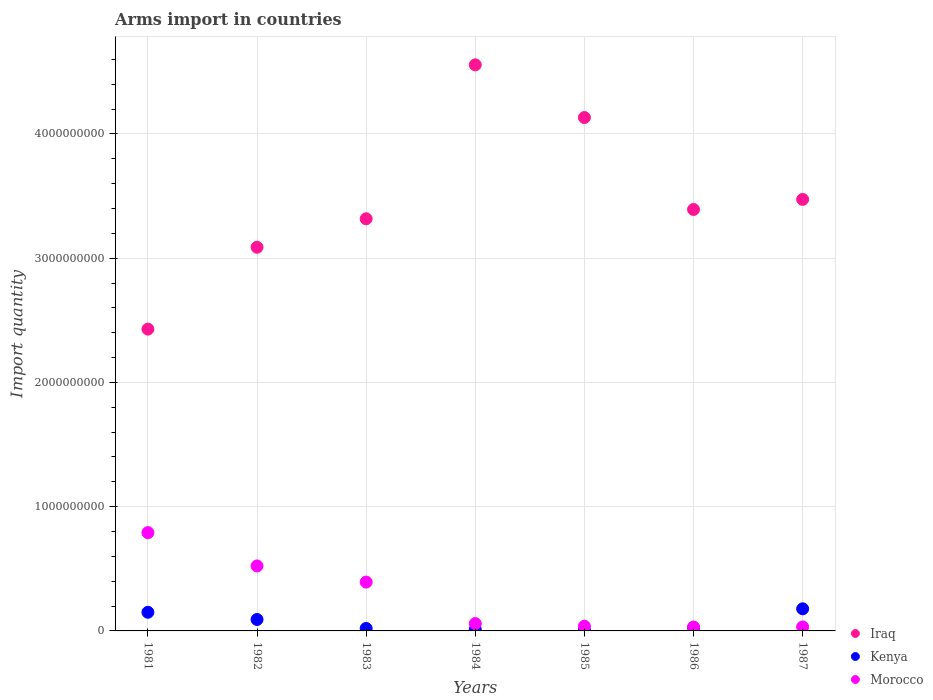What is the total arms import in Morocco in 1984?
Provide a short and direct response. 5.90e+07. Across all years, what is the maximum total arms import in Iraq?
Your answer should be very brief. 4.56e+09. Across all years, what is the minimum total arms import in Morocco?
Provide a succinct answer. 3.10e+07. In which year was the total arms import in Kenya maximum?
Your response must be concise. 1987. What is the total total arms import in Morocco in the graph?
Provide a short and direct response. 1.87e+09. What is the difference between the total arms import in Morocco in 1981 and that in 1982?
Make the answer very short. 2.68e+08. What is the difference between the total arms import in Morocco in 1985 and the total arms import in Iraq in 1983?
Make the answer very short. -3.28e+09. What is the average total arms import in Iraq per year?
Give a very brief answer. 3.48e+09. In the year 1984, what is the difference between the total arms import in Iraq and total arms import in Kenya?
Your answer should be compact. 4.54e+09. What is the ratio of the total arms import in Iraq in 1983 to that in 1984?
Ensure brevity in your answer.  0.73. Is the total arms import in Kenya in 1982 less than that in 1984?
Ensure brevity in your answer.  No. What is the difference between the highest and the second highest total arms import in Morocco?
Keep it short and to the point. 2.68e+08. What is the difference between the highest and the lowest total arms import in Morocco?
Keep it short and to the point. 7.60e+08. How many dotlines are there?
Offer a very short reply. 3. How many years are there in the graph?
Offer a very short reply. 7. What is the difference between two consecutive major ticks on the Y-axis?
Keep it short and to the point. 1.00e+09. Are the values on the major ticks of Y-axis written in scientific E-notation?
Make the answer very short. No. Does the graph contain any zero values?
Provide a succinct answer. No. Does the graph contain grids?
Your answer should be very brief. Yes. How are the legend labels stacked?
Offer a terse response. Vertical. What is the title of the graph?
Keep it short and to the point. Arms import in countries. Does "Marshall Islands" appear as one of the legend labels in the graph?
Offer a very short reply. No. What is the label or title of the Y-axis?
Make the answer very short. Import quantity. What is the Import quantity in Iraq in 1981?
Offer a very short reply. 2.43e+09. What is the Import quantity of Kenya in 1981?
Your response must be concise. 1.50e+08. What is the Import quantity in Morocco in 1981?
Provide a succinct answer. 7.91e+08. What is the Import quantity of Iraq in 1982?
Your response must be concise. 3.09e+09. What is the Import quantity of Kenya in 1982?
Offer a terse response. 9.20e+07. What is the Import quantity in Morocco in 1982?
Keep it short and to the point. 5.23e+08. What is the Import quantity in Iraq in 1983?
Make the answer very short. 3.32e+09. What is the Import quantity in Morocco in 1983?
Provide a succinct answer. 3.93e+08. What is the Import quantity in Iraq in 1984?
Ensure brevity in your answer.  4.56e+09. What is the Import quantity of Kenya in 1984?
Keep it short and to the point. 1.20e+07. What is the Import quantity of Morocco in 1984?
Your response must be concise. 5.90e+07. What is the Import quantity of Iraq in 1985?
Your answer should be compact. 4.13e+09. What is the Import quantity in Morocco in 1985?
Offer a terse response. 3.80e+07. What is the Import quantity in Iraq in 1986?
Offer a terse response. 3.39e+09. What is the Import quantity in Kenya in 1986?
Ensure brevity in your answer.  2.60e+07. What is the Import quantity in Morocco in 1986?
Provide a short and direct response. 3.10e+07. What is the Import quantity of Iraq in 1987?
Offer a very short reply. 3.47e+09. What is the Import quantity of Kenya in 1987?
Ensure brevity in your answer.  1.78e+08. What is the Import quantity of Morocco in 1987?
Your answer should be very brief. 3.20e+07. Across all years, what is the maximum Import quantity of Iraq?
Your answer should be compact. 4.56e+09. Across all years, what is the maximum Import quantity of Kenya?
Provide a short and direct response. 1.78e+08. Across all years, what is the maximum Import quantity of Morocco?
Offer a terse response. 7.91e+08. Across all years, what is the minimum Import quantity in Iraq?
Provide a short and direct response. 2.43e+09. Across all years, what is the minimum Import quantity in Morocco?
Keep it short and to the point. 3.10e+07. What is the total Import quantity of Iraq in the graph?
Offer a terse response. 2.44e+1. What is the total Import quantity in Kenya in the graph?
Ensure brevity in your answer.  4.84e+08. What is the total Import quantity of Morocco in the graph?
Provide a short and direct response. 1.87e+09. What is the difference between the Import quantity of Iraq in 1981 and that in 1982?
Give a very brief answer. -6.59e+08. What is the difference between the Import quantity of Kenya in 1981 and that in 1982?
Provide a short and direct response. 5.80e+07. What is the difference between the Import quantity in Morocco in 1981 and that in 1982?
Keep it short and to the point. 2.68e+08. What is the difference between the Import quantity in Iraq in 1981 and that in 1983?
Your answer should be very brief. -8.88e+08. What is the difference between the Import quantity in Kenya in 1981 and that in 1983?
Ensure brevity in your answer.  1.30e+08. What is the difference between the Import quantity of Morocco in 1981 and that in 1983?
Provide a succinct answer. 3.98e+08. What is the difference between the Import quantity of Iraq in 1981 and that in 1984?
Give a very brief answer. -2.13e+09. What is the difference between the Import quantity in Kenya in 1981 and that in 1984?
Provide a short and direct response. 1.38e+08. What is the difference between the Import quantity in Morocco in 1981 and that in 1984?
Keep it short and to the point. 7.32e+08. What is the difference between the Import quantity in Iraq in 1981 and that in 1985?
Your response must be concise. -1.70e+09. What is the difference between the Import quantity in Kenya in 1981 and that in 1985?
Provide a short and direct response. 1.44e+08. What is the difference between the Import quantity of Morocco in 1981 and that in 1985?
Your answer should be compact. 7.53e+08. What is the difference between the Import quantity of Iraq in 1981 and that in 1986?
Make the answer very short. -9.63e+08. What is the difference between the Import quantity in Kenya in 1981 and that in 1986?
Your response must be concise. 1.24e+08. What is the difference between the Import quantity of Morocco in 1981 and that in 1986?
Your response must be concise. 7.60e+08. What is the difference between the Import quantity in Iraq in 1981 and that in 1987?
Offer a terse response. -1.04e+09. What is the difference between the Import quantity of Kenya in 1981 and that in 1987?
Offer a very short reply. -2.80e+07. What is the difference between the Import quantity of Morocco in 1981 and that in 1987?
Make the answer very short. 7.59e+08. What is the difference between the Import quantity of Iraq in 1982 and that in 1983?
Offer a terse response. -2.29e+08. What is the difference between the Import quantity of Kenya in 1982 and that in 1983?
Offer a terse response. 7.20e+07. What is the difference between the Import quantity in Morocco in 1982 and that in 1983?
Your answer should be very brief. 1.30e+08. What is the difference between the Import quantity of Iraq in 1982 and that in 1984?
Your response must be concise. -1.47e+09. What is the difference between the Import quantity of Kenya in 1982 and that in 1984?
Your answer should be very brief. 8.00e+07. What is the difference between the Import quantity of Morocco in 1982 and that in 1984?
Make the answer very short. 4.64e+08. What is the difference between the Import quantity in Iraq in 1982 and that in 1985?
Offer a very short reply. -1.04e+09. What is the difference between the Import quantity in Kenya in 1982 and that in 1985?
Provide a short and direct response. 8.60e+07. What is the difference between the Import quantity of Morocco in 1982 and that in 1985?
Keep it short and to the point. 4.85e+08. What is the difference between the Import quantity of Iraq in 1982 and that in 1986?
Offer a very short reply. -3.04e+08. What is the difference between the Import quantity of Kenya in 1982 and that in 1986?
Offer a terse response. 6.60e+07. What is the difference between the Import quantity in Morocco in 1982 and that in 1986?
Keep it short and to the point. 4.92e+08. What is the difference between the Import quantity in Iraq in 1982 and that in 1987?
Provide a short and direct response. -3.85e+08. What is the difference between the Import quantity of Kenya in 1982 and that in 1987?
Give a very brief answer. -8.60e+07. What is the difference between the Import quantity of Morocco in 1982 and that in 1987?
Keep it short and to the point. 4.91e+08. What is the difference between the Import quantity of Iraq in 1983 and that in 1984?
Your answer should be very brief. -1.24e+09. What is the difference between the Import quantity in Kenya in 1983 and that in 1984?
Ensure brevity in your answer.  8.00e+06. What is the difference between the Import quantity in Morocco in 1983 and that in 1984?
Your response must be concise. 3.34e+08. What is the difference between the Import quantity of Iraq in 1983 and that in 1985?
Ensure brevity in your answer.  -8.15e+08. What is the difference between the Import quantity of Kenya in 1983 and that in 1985?
Offer a terse response. 1.40e+07. What is the difference between the Import quantity of Morocco in 1983 and that in 1985?
Provide a short and direct response. 3.55e+08. What is the difference between the Import quantity of Iraq in 1983 and that in 1986?
Give a very brief answer. -7.50e+07. What is the difference between the Import quantity of Kenya in 1983 and that in 1986?
Your answer should be very brief. -6.00e+06. What is the difference between the Import quantity of Morocco in 1983 and that in 1986?
Your response must be concise. 3.62e+08. What is the difference between the Import quantity of Iraq in 1983 and that in 1987?
Offer a terse response. -1.56e+08. What is the difference between the Import quantity in Kenya in 1983 and that in 1987?
Ensure brevity in your answer.  -1.58e+08. What is the difference between the Import quantity in Morocco in 1983 and that in 1987?
Ensure brevity in your answer.  3.61e+08. What is the difference between the Import quantity of Iraq in 1984 and that in 1985?
Ensure brevity in your answer.  4.24e+08. What is the difference between the Import quantity in Kenya in 1984 and that in 1985?
Keep it short and to the point. 6.00e+06. What is the difference between the Import quantity in Morocco in 1984 and that in 1985?
Keep it short and to the point. 2.10e+07. What is the difference between the Import quantity of Iraq in 1984 and that in 1986?
Make the answer very short. 1.16e+09. What is the difference between the Import quantity of Kenya in 1984 and that in 1986?
Offer a terse response. -1.40e+07. What is the difference between the Import quantity of Morocco in 1984 and that in 1986?
Make the answer very short. 2.80e+07. What is the difference between the Import quantity of Iraq in 1984 and that in 1987?
Give a very brief answer. 1.08e+09. What is the difference between the Import quantity in Kenya in 1984 and that in 1987?
Your response must be concise. -1.66e+08. What is the difference between the Import quantity of Morocco in 1984 and that in 1987?
Ensure brevity in your answer.  2.70e+07. What is the difference between the Import quantity in Iraq in 1985 and that in 1986?
Keep it short and to the point. 7.40e+08. What is the difference between the Import quantity of Kenya in 1985 and that in 1986?
Your answer should be compact. -2.00e+07. What is the difference between the Import quantity in Morocco in 1985 and that in 1986?
Your answer should be very brief. 7.00e+06. What is the difference between the Import quantity in Iraq in 1985 and that in 1987?
Give a very brief answer. 6.59e+08. What is the difference between the Import quantity in Kenya in 1985 and that in 1987?
Offer a very short reply. -1.72e+08. What is the difference between the Import quantity in Iraq in 1986 and that in 1987?
Your response must be concise. -8.10e+07. What is the difference between the Import quantity in Kenya in 1986 and that in 1987?
Provide a short and direct response. -1.52e+08. What is the difference between the Import quantity in Iraq in 1981 and the Import quantity in Kenya in 1982?
Provide a succinct answer. 2.34e+09. What is the difference between the Import quantity in Iraq in 1981 and the Import quantity in Morocco in 1982?
Give a very brief answer. 1.91e+09. What is the difference between the Import quantity in Kenya in 1981 and the Import quantity in Morocco in 1982?
Offer a very short reply. -3.73e+08. What is the difference between the Import quantity of Iraq in 1981 and the Import quantity of Kenya in 1983?
Keep it short and to the point. 2.41e+09. What is the difference between the Import quantity of Iraq in 1981 and the Import quantity of Morocco in 1983?
Your answer should be very brief. 2.04e+09. What is the difference between the Import quantity in Kenya in 1981 and the Import quantity in Morocco in 1983?
Ensure brevity in your answer.  -2.43e+08. What is the difference between the Import quantity in Iraq in 1981 and the Import quantity in Kenya in 1984?
Make the answer very short. 2.42e+09. What is the difference between the Import quantity in Iraq in 1981 and the Import quantity in Morocco in 1984?
Your answer should be compact. 2.37e+09. What is the difference between the Import quantity in Kenya in 1981 and the Import quantity in Morocco in 1984?
Provide a succinct answer. 9.10e+07. What is the difference between the Import quantity of Iraq in 1981 and the Import quantity of Kenya in 1985?
Provide a short and direct response. 2.42e+09. What is the difference between the Import quantity of Iraq in 1981 and the Import quantity of Morocco in 1985?
Your answer should be compact. 2.39e+09. What is the difference between the Import quantity of Kenya in 1981 and the Import quantity of Morocco in 1985?
Provide a succinct answer. 1.12e+08. What is the difference between the Import quantity in Iraq in 1981 and the Import quantity in Kenya in 1986?
Keep it short and to the point. 2.40e+09. What is the difference between the Import quantity in Iraq in 1981 and the Import quantity in Morocco in 1986?
Keep it short and to the point. 2.40e+09. What is the difference between the Import quantity of Kenya in 1981 and the Import quantity of Morocco in 1986?
Provide a succinct answer. 1.19e+08. What is the difference between the Import quantity in Iraq in 1981 and the Import quantity in Kenya in 1987?
Your response must be concise. 2.25e+09. What is the difference between the Import quantity of Iraq in 1981 and the Import quantity of Morocco in 1987?
Make the answer very short. 2.40e+09. What is the difference between the Import quantity in Kenya in 1981 and the Import quantity in Morocco in 1987?
Ensure brevity in your answer.  1.18e+08. What is the difference between the Import quantity of Iraq in 1982 and the Import quantity of Kenya in 1983?
Give a very brief answer. 3.07e+09. What is the difference between the Import quantity in Iraq in 1982 and the Import quantity in Morocco in 1983?
Your answer should be very brief. 2.70e+09. What is the difference between the Import quantity in Kenya in 1982 and the Import quantity in Morocco in 1983?
Give a very brief answer. -3.01e+08. What is the difference between the Import quantity of Iraq in 1982 and the Import quantity of Kenya in 1984?
Ensure brevity in your answer.  3.08e+09. What is the difference between the Import quantity of Iraq in 1982 and the Import quantity of Morocco in 1984?
Provide a short and direct response. 3.03e+09. What is the difference between the Import quantity of Kenya in 1982 and the Import quantity of Morocco in 1984?
Keep it short and to the point. 3.30e+07. What is the difference between the Import quantity of Iraq in 1982 and the Import quantity of Kenya in 1985?
Provide a succinct answer. 3.08e+09. What is the difference between the Import quantity in Iraq in 1982 and the Import quantity in Morocco in 1985?
Your answer should be compact. 3.05e+09. What is the difference between the Import quantity in Kenya in 1982 and the Import quantity in Morocco in 1985?
Offer a terse response. 5.40e+07. What is the difference between the Import quantity of Iraq in 1982 and the Import quantity of Kenya in 1986?
Your answer should be compact. 3.06e+09. What is the difference between the Import quantity of Iraq in 1982 and the Import quantity of Morocco in 1986?
Make the answer very short. 3.06e+09. What is the difference between the Import quantity in Kenya in 1982 and the Import quantity in Morocco in 1986?
Make the answer very short. 6.10e+07. What is the difference between the Import quantity in Iraq in 1982 and the Import quantity in Kenya in 1987?
Provide a short and direct response. 2.91e+09. What is the difference between the Import quantity in Iraq in 1982 and the Import quantity in Morocco in 1987?
Offer a terse response. 3.06e+09. What is the difference between the Import quantity of Kenya in 1982 and the Import quantity of Morocco in 1987?
Your answer should be compact. 6.00e+07. What is the difference between the Import quantity of Iraq in 1983 and the Import quantity of Kenya in 1984?
Ensure brevity in your answer.  3.30e+09. What is the difference between the Import quantity of Iraq in 1983 and the Import quantity of Morocco in 1984?
Provide a succinct answer. 3.26e+09. What is the difference between the Import quantity of Kenya in 1983 and the Import quantity of Morocco in 1984?
Ensure brevity in your answer.  -3.90e+07. What is the difference between the Import quantity of Iraq in 1983 and the Import quantity of Kenya in 1985?
Ensure brevity in your answer.  3.31e+09. What is the difference between the Import quantity in Iraq in 1983 and the Import quantity in Morocco in 1985?
Keep it short and to the point. 3.28e+09. What is the difference between the Import quantity of Kenya in 1983 and the Import quantity of Morocco in 1985?
Provide a succinct answer. -1.80e+07. What is the difference between the Import quantity in Iraq in 1983 and the Import quantity in Kenya in 1986?
Your response must be concise. 3.29e+09. What is the difference between the Import quantity of Iraq in 1983 and the Import quantity of Morocco in 1986?
Offer a terse response. 3.29e+09. What is the difference between the Import quantity of Kenya in 1983 and the Import quantity of Morocco in 1986?
Make the answer very short. -1.10e+07. What is the difference between the Import quantity of Iraq in 1983 and the Import quantity of Kenya in 1987?
Your response must be concise. 3.14e+09. What is the difference between the Import quantity in Iraq in 1983 and the Import quantity in Morocco in 1987?
Keep it short and to the point. 3.28e+09. What is the difference between the Import quantity in Kenya in 1983 and the Import quantity in Morocco in 1987?
Provide a succinct answer. -1.20e+07. What is the difference between the Import quantity of Iraq in 1984 and the Import quantity of Kenya in 1985?
Your answer should be very brief. 4.55e+09. What is the difference between the Import quantity of Iraq in 1984 and the Import quantity of Morocco in 1985?
Provide a short and direct response. 4.52e+09. What is the difference between the Import quantity of Kenya in 1984 and the Import quantity of Morocco in 1985?
Provide a succinct answer. -2.60e+07. What is the difference between the Import quantity in Iraq in 1984 and the Import quantity in Kenya in 1986?
Your response must be concise. 4.53e+09. What is the difference between the Import quantity of Iraq in 1984 and the Import quantity of Morocco in 1986?
Your response must be concise. 4.52e+09. What is the difference between the Import quantity in Kenya in 1984 and the Import quantity in Morocco in 1986?
Your response must be concise. -1.90e+07. What is the difference between the Import quantity in Iraq in 1984 and the Import quantity in Kenya in 1987?
Your answer should be very brief. 4.38e+09. What is the difference between the Import quantity of Iraq in 1984 and the Import quantity of Morocco in 1987?
Provide a short and direct response. 4.52e+09. What is the difference between the Import quantity in Kenya in 1984 and the Import quantity in Morocco in 1987?
Your answer should be very brief. -2.00e+07. What is the difference between the Import quantity in Iraq in 1985 and the Import quantity in Kenya in 1986?
Your answer should be very brief. 4.11e+09. What is the difference between the Import quantity of Iraq in 1985 and the Import quantity of Morocco in 1986?
Your response must be concise. 4.10e+09. What is the difference between the Import quantity of Kenya in 1985 and the Import quantity of Morocco in 1986?
Give a very brief answer. -2.50e+07. What is the difference between the Import quantity of Iraq in 1985 and the Import quantity of Kenya in 1987?
Your response must be concise. 3.95e+09. What is the difference between the Import quantity of Iraq in 1985 and the Import quantity of Morocco in 1987?
Provide a short and direct response. 4.10e+09. What is the difference between the Import quantity in Kenya in 1985 and the Import quantity in Morocco in 1987?
Keep it short and to the point. -2.60e+07. What is the difference between the Import quantity of Iraq in 1986 and the Import quantity of Kenya in 1987?
Your response must be concise. 3.21e+09. What is the difference between the Import quantity in Iraq in 1986 and the Import quantity in Morocco in 1987?
Offer a terse response. 3.36e+09. What is the difference between the Import quantity in Kenya in 1986 and the Import quantity in Morocco in 1987?
Ensure brevity in your answer.  -6.00e+06. What is the average Import quantity of Iraq per year?
Offer a terse response. 3.48e+09. What is the average Import quantity of Kenya per year?
Your response must be concise. 6.91e+07. What is the average Import quantity of Morocco per year?
Keep it short and to the point. 2.67e+08. In the year 1981, what is the difference between the Import quantity of Iraq and Import quantity of Kenya?
Your response must be concise. 2.28e+09. In the year 1981, what is the difference between the Import quantity in Iraq and Import quantity in Morocco?
Provide a short and direct response. 1.64e+09. In the year 1981, what is the difference between the Import quantity in Kenya and Import quantity in Morocco?
Make the answer very short. -6.41e+08. In the year 1982, what is the difference between the Import quantity in Iraq and Import quantity in Kenya?
Provide a short and direct response. 3.00e+09. In the year 1982, what is the difference between the Import quantity of Iraq and Import quantity of Morocco?
Offer a very short reply. 2.56e+09. In the year 1982, what is the difference between the Import quantity in Kenya and Import quantity in Morocco?
Make the answer very short. -4.31e+08. In the year 1983, what is the difference between the Import quantity of Iraq and Import quantity of Kenya?
Provide a short and direct response. 3.30e+09. In the year 1983, what is the difference between the Import quantity in Iraq and Import quantity in Morocco?
Give a very brief answer. 2.92e+09. In the year 1983, what is the difference between the Import quantity of Kenya and Import quantity of Morocco?
Provide a succinct answer. -3.73e+08. In the year 1984, what is the difference between the Import quantity in Iraq and Import quantity in Kenya?
Give a very brief answer. 4.54e+09. In the year 1984, what is the difference between the Import quantity of Iraq and Import quantity of Morocco?
Your answer should be compact. 4.50e+09. In the year 1984, what is the difference between the Import quantity of Kenya and Import quantity of Morocco?
Provide a short and direct response. -4.70e+07. In the year 1985, what is the difference between the Import quantity in Iraq and Import quantity in Kenya?
Make the answer very short. 4.13e+09. In the year 1985, what is the difference between the Import quantity of Iraq and Import quantity of Morocco?
Ensure brevity in your answer.  4.09e+09. In the year 1985, what is the difference between the Import quantity in Kenya and Import quantity in Morocco?
Offer a very short reply. -3.20e+07. In the year 1986, what is the difference between the Import quantity in Iraq and Import quantity in Kenya?
Keep it short and to the point. 3.37e+09. In the year 1986, what is the difference between the Import quantity in Iraq and Import quantity in Morocco?
Ensure brevity in your answer.  3.36e+09. In the year 1986, what is the difference between the Import quantity in Kenya and Import quantity in Morocco?
Offer a very short reply. -5.00e+06. In the year 1987, what is the difference between the Import quantity of Iraq and Import quantity of Kenya?
Offer a terse response. 3.30e+09. In the year 1987, what is the difference between the Import quantity of Iraq and Import quantity of Morocco?
Give a very brief answer. 3.44e+09. In the year 1987, what is the difference between the Import quantity in Kenya and Import quantity in Morocco?
Provide a succinct answer. 1.46e+08. What is the ratio of the Import quantity of Iraq in 1981 to that in 1982?
Make the answer very short. 0.79. What is the ratio of the Import quantity in Kenya in 1981 to that in 1982?
Offer a very short reply. 1.63. What is the ratio of the Import quantity of Morocco in 1981 to that in 1982?
Provide a succinct answer. 1.51. What is the ratio of the Import quantity in Iraq in 1981 to that in 1983?
Your response must be concise. 0.73. What is the ratio of the Import quantity of Morocco in 1981 to that in 1983?
Give a very brief answer. 2.01. What is the ratio of the Import quantity in Iraq in 1981 to that in 1984?
Keep it short and to the point. 0.53. What is the ratio of the Import quantity of Kenya in 1981 to that in 1984?
Make the answer very short. 12.5. What is the ratio of the Import quantity of Morocco in 1981 to that in 1984?
Keep it short and to the point. 13.41. What is the ratio of the Import quantity of Iraq in 1981 to that in 1985?
Your answer should be compact. 0.59. What is the ratio of the Import quantity of Morocco in 1981 to that in 1985?
Keep it short and to the point. 20.82. What is the ratio of the Import quantity of Iraq in 1981 to that in 1986?
Ensure brevity in your answer.  0.72. What is the ratio of the Import quantity of Kenya in 1981 to that in 1986?
Offer a very short reply. 5.77. What is the ratio of the Import quantity of Morocco in 1981 to that in 1986?
Give a very brief answer. 25.52. What is the ratio of the Import quantity in Iraq in 1981 to that in 1987?
Ensure brevity in your answer.  0.7. What is the ratio of the Import quantity in Kenya in 1981 to that in 1987?
Make the answer very short. 0.84. What is the ratio of the Import quantity of Morocco in 1981 to that in 1987?
Your response must be concise. 24.72. What is the ratio of the Import quantity of Iraq in 1982 to that in 1983?
Keep it short and to the point. 0.93. What is the ratio of the Import quantity in Morocco in 1982 to that in 1983?
Give a very brief answer. 1.33. What is the ratio of the Import quantity in Iraq in 1982 to that in 1984?
Provide a short and direct response. 0.68. What is the ratio of the Import quantity in Kenya in 1982 to that in 1984?
Provide a short and direct response. 7.67. What is the ratio of the Import quantity in Morocco in 1982 to that in 1984?
Make the answer very short. 8.86. What is the ratio of the Import quantity of Iraq in 1982 to that in 1985?
Offer a very short reply. 0.75. What is the ratio of the Import quantity of Kenya in 1982 to that in 1985?
Your response must be concise. 15.33. What is the ratio of the Import quantity in Morocco in 1982 to that in 1985?
Offer a terse response. 13.76. What is the ratio of the Import quantity of Iraq in 1982 to that in 1986?
Ensure brevity in your answer.  0.91. What is the ratio of the Import quantity of Kenya in 1982 to that in 1986?
Your answer should be very brief. 3.54. What is the ratio of the Import quantity of Morocco in 1982 to that in 1986?
Your response must be concise. 16.87. What is the ratio of the Import quantity in Iraq in 1982 to that in 1987?
Keep it short and to the point. 0.89. What is the ratio of the Import quantity in Kenya in 1982 to that in 1987?
Your response must be concise. 0.52. What is the ratio of the Import quantity in Morocco in 1982 to that in 1987?
Your answer should be very brief. 16.34. What is the ratio of the Import quantity in Iraq in 1983 to that in 1984?
Provide a succinct answer. 0.73. What is the ratio of the Import quantity of Kenya in 1983 to that in 1984?
Ensure brevity in your answer.  1.67. What is the ratio of the Import quantity in Morocco in 1983 to that in 1984?
Give a very brief answer. 6.66. What is the ratio of the Import quantity of Iraq in 1983 to that in 1985?
Your answer should be very brief. 0.8. What is the ratio of the Import quantity of Kenya in 1983 to that in 1985?
Make the answer very short. 3.33. What is the ratio of the Import quantity of Morocco in 1983 to that in 1985?
Provide a succinct answer. 10.34. What is the ratio of the Import quantity of Iraq in 1983 to that in 1986?
Provide a short and direct response. 0.98. What is the ratio of the Import quantity in Kenya in 1983 to that in 1986?
Ensure brevity in your answer.  0.77. What is the ratio of the Import quantity of Morocco in 1983 to that in 1986?
Offer a very short reply. 12.68. What is the ratio of the Import quantity of Iraq in 1983 to that in 1987?
Offer a very short reply. 0.96. What is the ratio of the Import quantity in Kenya in 1983 to that in 1987?
Keep it short and to the point. 0.11. What is the ratio of the Import quantity in Morocco in 1983 to that in 1987?
Offer a terse response. 12.28. What is the ratio of the Import quantity of Iraq in 1984 to that in 1985?
Provide a short and direct response. 1.1. What is the ratio of the Import quantity of Morocco in 1984 to that in 1985?
Give a very brief answer. 1.55. What is the ratio of the Import quantity of Iraq in 1984 to that in 1986?
Provide a short and direct response. 1.34. What is the ratio of the Import quantity in Kenya in 1984 to that in 1986?
Keep it short and to the point. 0.46. What is the ratio of the Import quantity in Morocco in 1984 to that in 1986?
Your answer should be very brief. 1.9. What is the ratio of the Import quantity of Iraq in 1984 to that in 1987?
Offer a terse response. 1.31. What is the ratio of the Import quantity in Kenya in 1984 to that in 1987?
Ensure brevity in your answer.  0.07. What is the ratio of the Import quantity in Morocco in 1984 to that in 1987?
Provide a succinct answer. 1.84. What is the ratio of the Import quantity in Iraq in 1985 to that in 1986?
Offer a very short reply. 1.22. What is the ratio of the Import quantity of Kenya in 1985 to that in 1986?
Offer a terse response. 0.23. What is the ratio of the Import quantity of Morocco in 1985 to that in 1986?
Your response must be concise. 1.23. What is the ratio of the Import quantity in Iraq in 1985 to that in 1987?
Provide a succinct answer. 1.19. What is the ratio of the Import quantity of Kenya in 1985 to that in 1987?
Your answer should be compact. 0.03. What is the ratio of the Import quantity in Morocco in 1985 to that in 1987?
Offer a terse response. 1.19. What is the ratio of the Import quantity of Iraq in 1986 to that in 1987?
Offer a terse response. 0.98. What is the ratio of the Import quantity in Kenya in 1986 to that in 1987?
Offer a very short reply. 0.15. What is the ratio of the Import quantity of Morocco in 1986 to that in 1987?
Your answer should be very brief. 0.97. What is the difference between the highest and the second highest Import quantity of Iraq?
Your answer should be compact. 4.24e+08. What is the difference between the highest and the second highest Import quantity in Kenya?
Offer a terse response. 2.80e+07. What is the difference between the highest and the second highest Import quantity in Morocco?
Provide a succinct answer. 2.68e+08. What is the difference between the highest and the lowest Import quantity in Iraq?
Keep it short and to the point. 2.13e+09. What is the difference between the highest and the lowest Import quantity in Kenya?
Ensure brevity in your answer.  1.72e+08. What is the difference between the highest and the lowest Import quantity in Morocco?
Keep it short and to the point. 7.60e+08. 